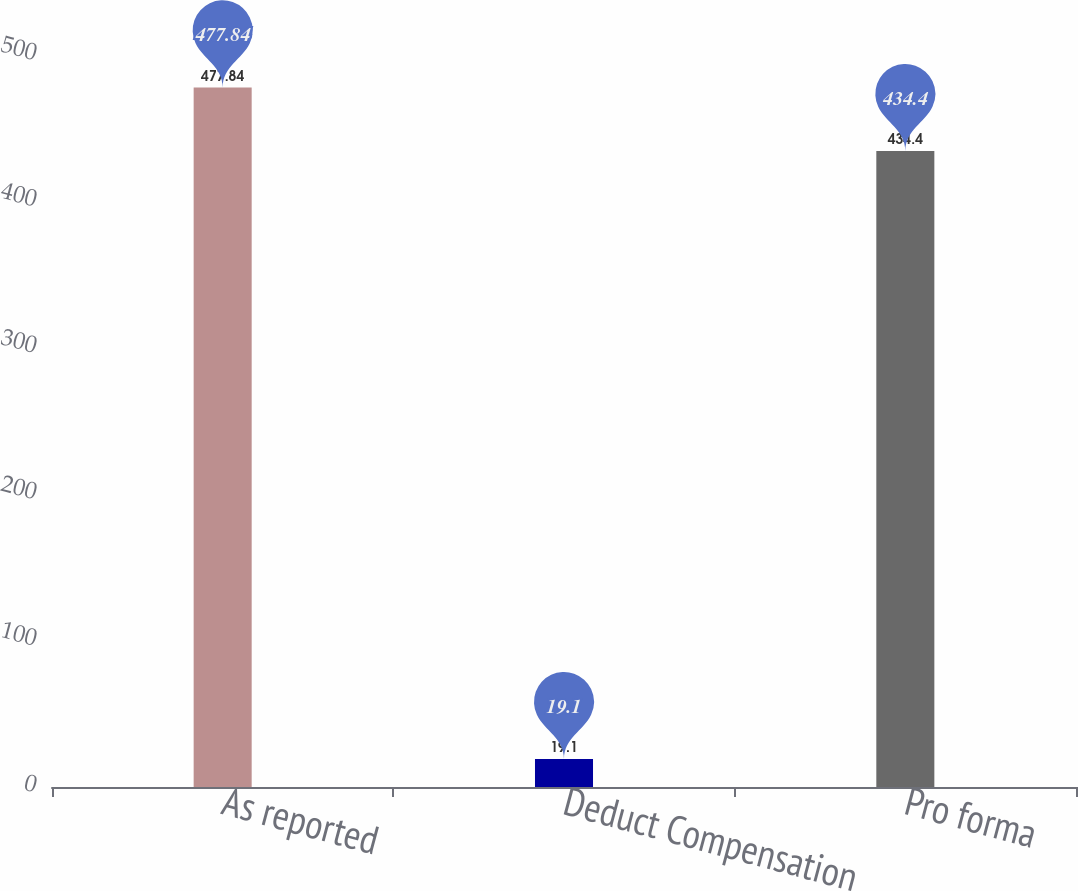Convert chart. <chart><loc_0><loc_0><loc_500><loc_500><bar_chart><fcel>As reported<fcel>Deduct Compensation<fcel>Pro forma<nl><fcel>477.84<fcel>19.1<fcel>434.4<nl></chart> 